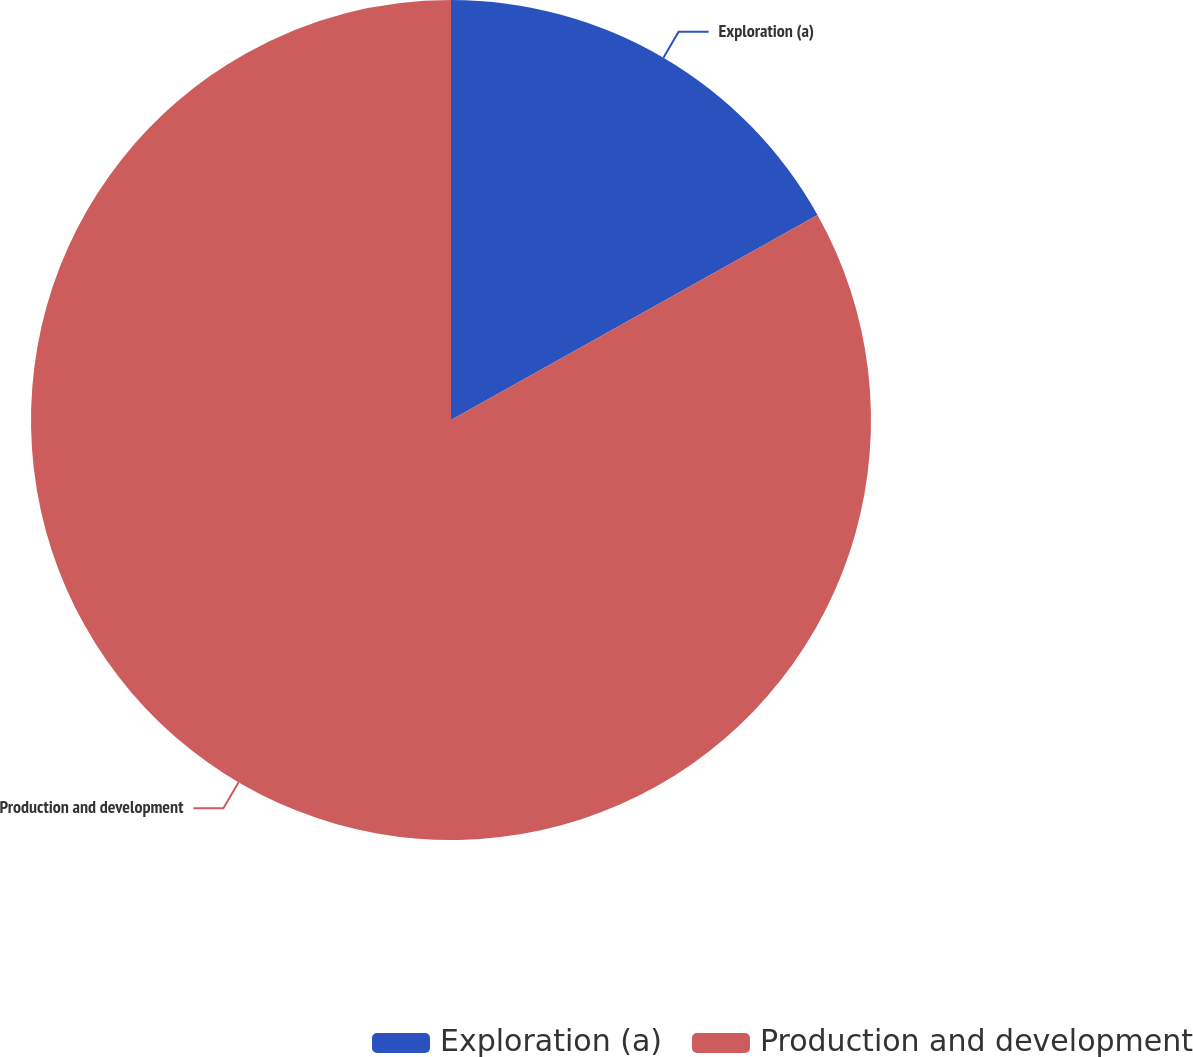Convert chart to OTSL. <chart><loc_0><loc_0><loc_500><loc_500><pie_chart><fcel>Exploration (a)<fcel>Production and development<nl><fcel>16.88%<fcel>83.12%<nl></chart> 